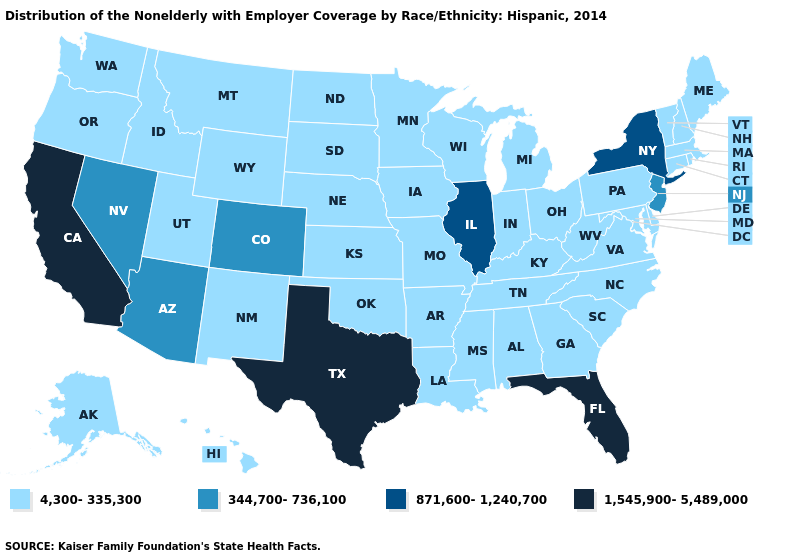What is the value of Kentucky?
Give a very brief answer. 4,300-335,300. Name the states that have a value in the range 4,300-335,300?
Be succinct. Alabama, Alaska, Arkansas, Connecticut, Delaware, Georgia, Hawaii, Idaho, Indiana, Iowa, Kansas, Kentucky, Louisiana, Maine, Maryland, Massachusetts, Michigan, Minnesota, Mississippi, Missouri, Montana, Nebraska, New Hampshire, New Mexico, North Carolina, North Dakota, Ohio, Oklahoma, Oregon, Pennsylvania, Rhode Island, South Carolina, South Dakota, Tennessee, Utah, Vermont, Virginia, Washington, West Virginia, Wisconsin, Wyoming. Among the states that border Rhode Island , which have the lowest value?
Quick response, please. Connecticut, Massachusetts. What is the value of Iowa?
Give a very brief answer. 4,300-335,300. Does Arizona have a higher value than Oklahoma?
Keep it brief. Yes. Is the legend a continuous bar?
Short answer required. No. What is the highest value in the West ?
Concise answer only. 1,545,900-5,489,000. Is the legend a continuous bar?
Write a very short answer. No. Name the states that have a value in the range 1,545,900-5,489,000?
Be succinct. California, Florida, Texas. Does Utah have the highest value in the USA?
Give a very brief answer. No. Among the states that border Wisconsin , does Illinois have the highest value?
Keep it brief. Yes. Name the states that have a value in the range 871,600-1,240,700?
Keep it brief. Illinois, New York. What is the highest value in the South ?
Concise answer only. 1,545,900-5,489,000. Name the states that have a value in the range 1,545,900-5,489,000?
Short answer required. California, Florida, Texas. What is the value of Michigan?
Concise answer only. 4,300-335,300. 